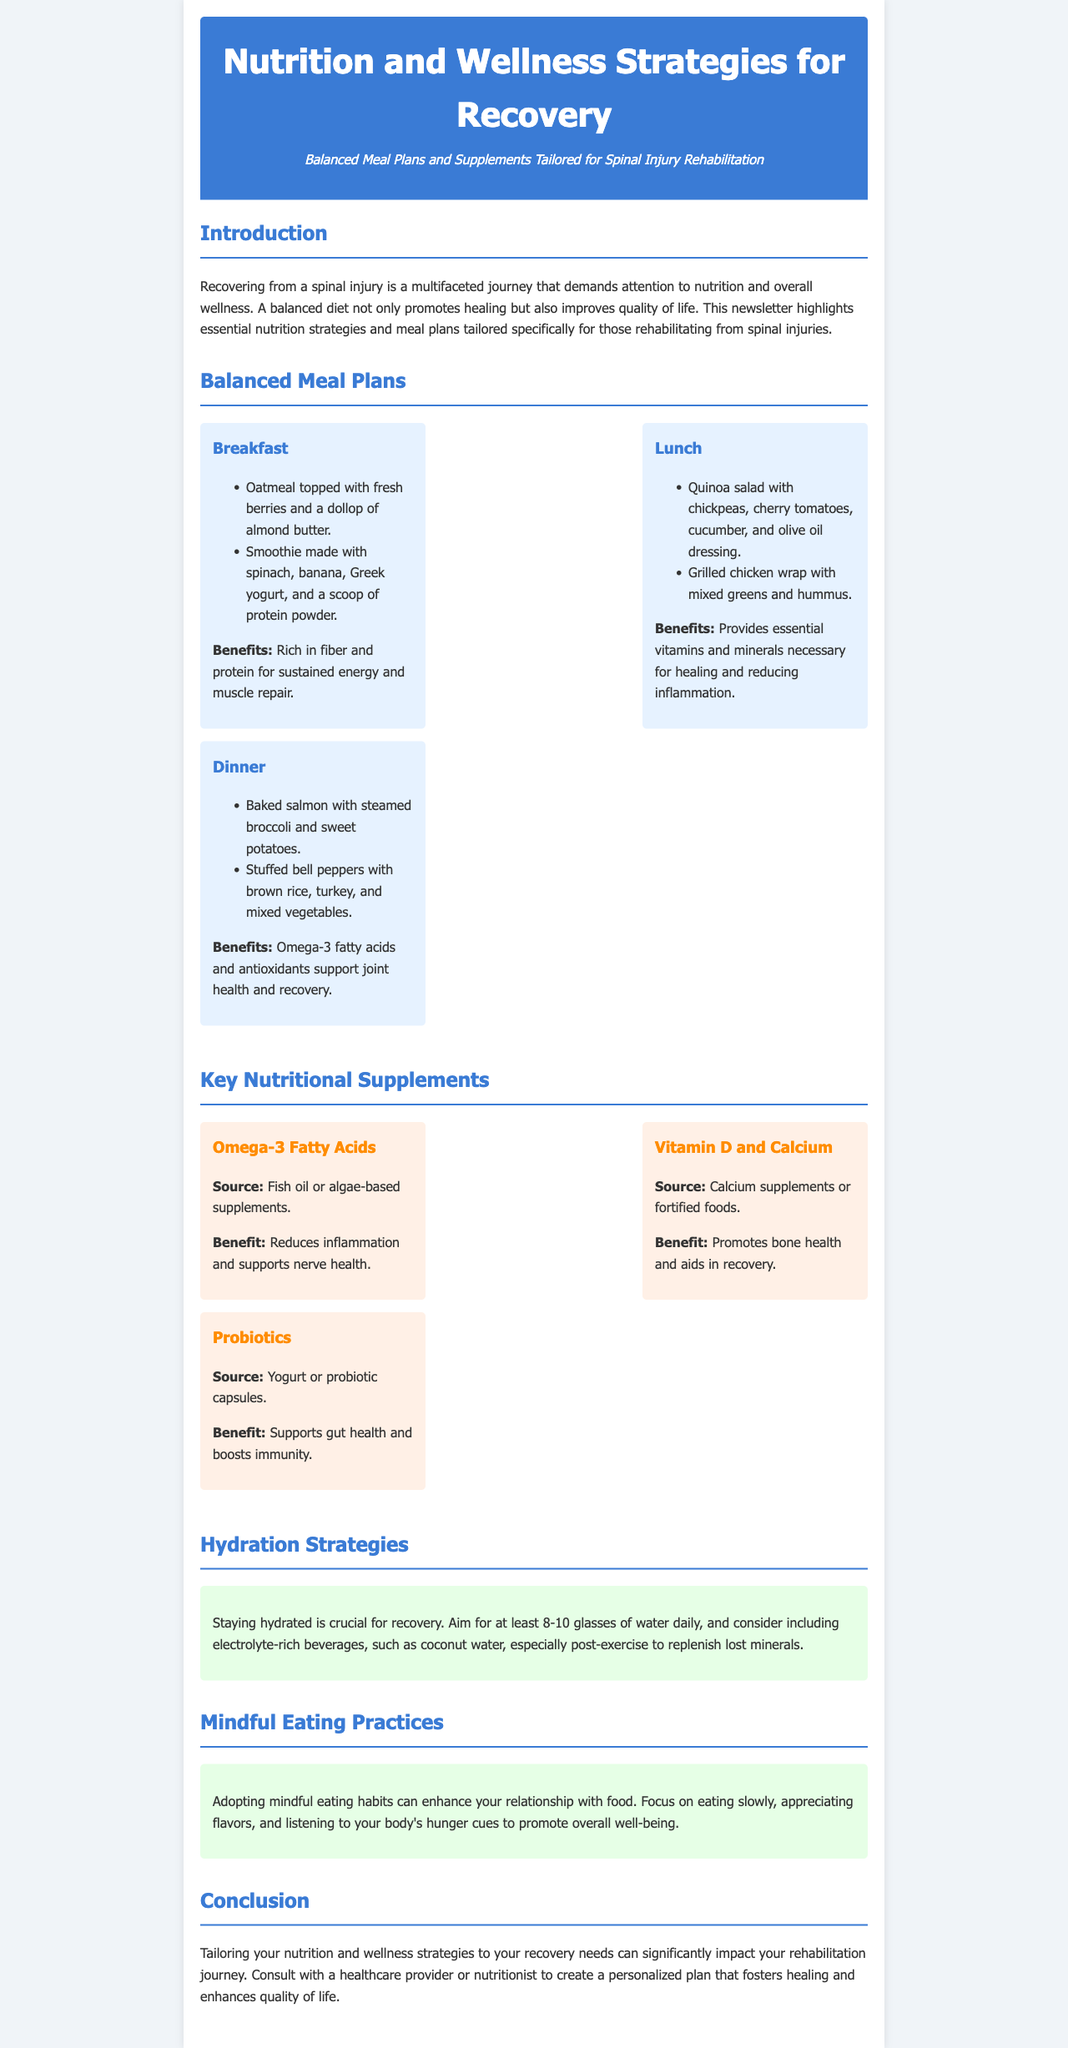What is the primary focus of the newsletter? The newsletter emphasizes the importance of nutrition and wellness strategies in the recovery process from spinal injuries.
Answer: Nutrition and wellness strategies for recovery How many meals are recommended for the balanced meal plans? There are three meal categories provided: Breakfast, Lunch, and Dinner.
Answer: Three What is one example of a breakfast option? The document lists oatmeal topped with fresh berries and a dollop of almond butter as a breakfast option.
Answer: Oatmeal topped with fresh berries and almond butter What is the benefit of Omega-3 fatty acids? It reduces inflammation and supports nerve health, as mentioned in the supplement section.
Answer: Reduces inflammation and supports nerve health How many glasses of water should one aim to drink daily? The document suggests aiming for at least 8-10 glasses of water each day for proper hydration.
Answer: 8-10 glasses What type of eating practices does the newsletter advise adopting? Mindful eating practices are recommended to improve the relationship with food.
Answer: Mindful eating practices Which supplement is highlighted for promoting bone health? Vitamin D and Calcium are noted for their role in bone health and recovery.
Answer: Vitamin D and Calcium What is the recommended way to enhance one's relationship with food? The document suggests focusing on eating slowly and appreciating flavors.
Answer: Eating slowly and appreciating flavors 